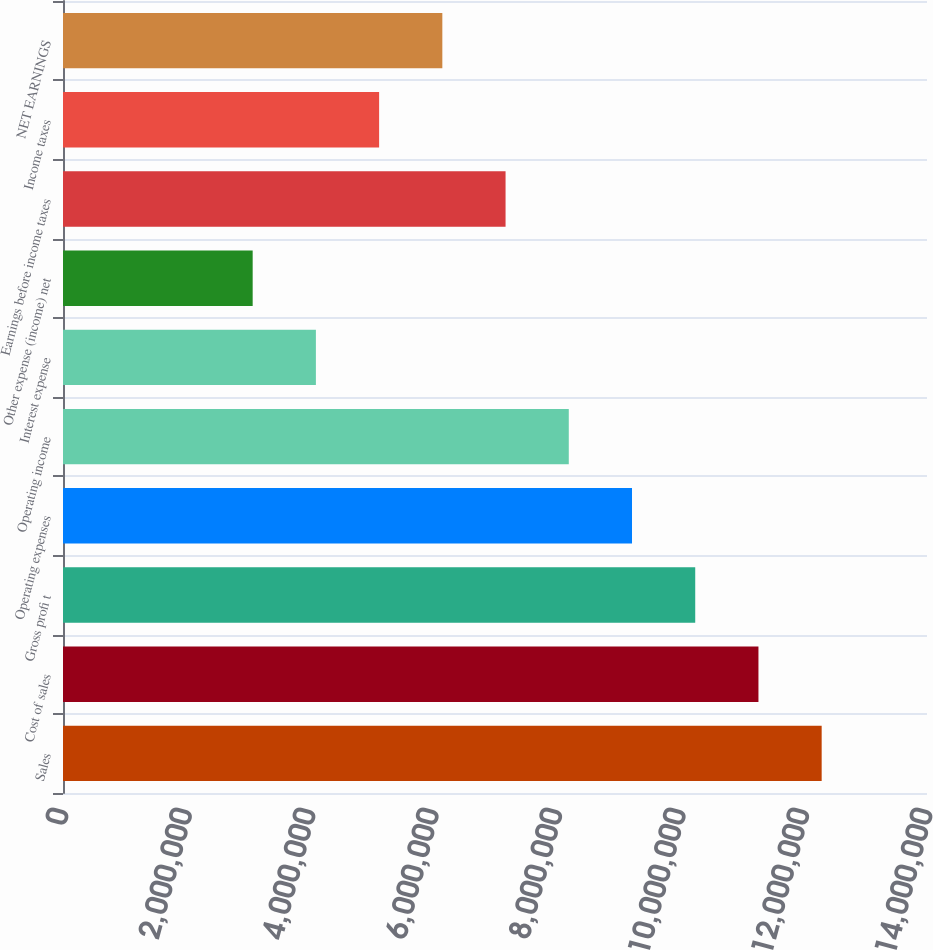Convert chart. <chart><loc_0><loc_0><loc_500><loc_500><bar_chart><fcel>Sales<fcel>Cost of sales<fcel>Gross profi t<fcel>Operating expenses<fcel>Operating income<fcel>Interest expense<fcel>Other expense (income) net<fcel>Earnings before income taxes<fcel>Income taxes<fcel>NET EARNINGS<nl><fcel>1.22933e+07<fcel>1.12689e+07<fcel>1.02444e+07<fcel>9.21998e+06<fcel>8.19554e+06<fcel>4.09777e+06<fcel>3.07333e+06<fcel>7.17109e+06<fcel>5.12221e+06<fcel>6.14665e+06<nl></chart> 